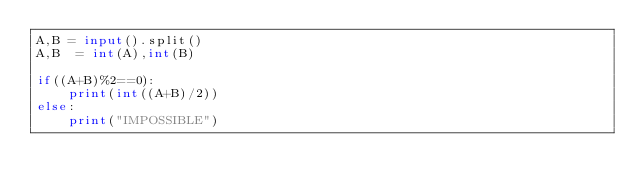Convert code to text. <code><loc_0><loc_0><loc_500><loc_500><_Python_>A,B = input().split()
A,B  = int(A),int(B)

if((A+B)%2==0):
    print(int((A+B)/2))
else:
    print("IMPOSSIBLE")</code> 